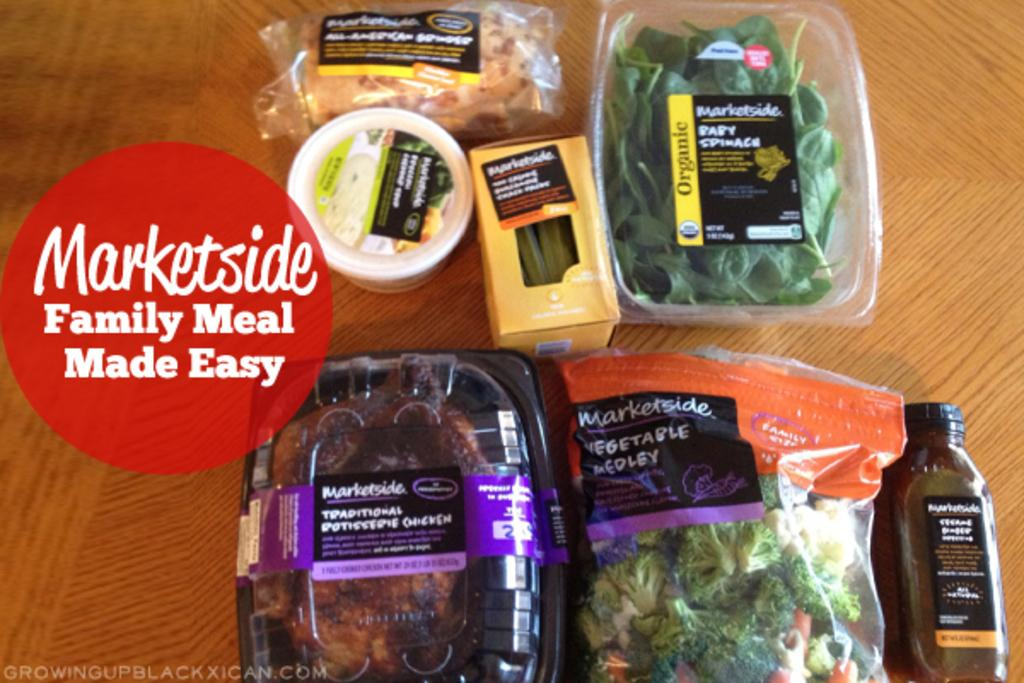<image>
Present a compact description of the photo's key features. an ad for Marketside Family Meal Made Easy and several pre-made products 